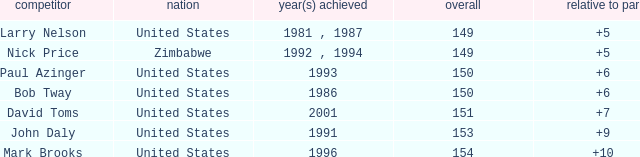Which player won in 1993? Paul Azinger. 